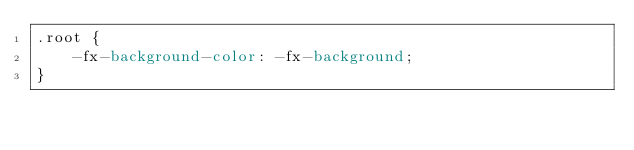<code> <loc_0><loc_0><loc_500><loc_500><_CSS_>.root {
    -fx-background-color: -fx-background;
}

</code> 